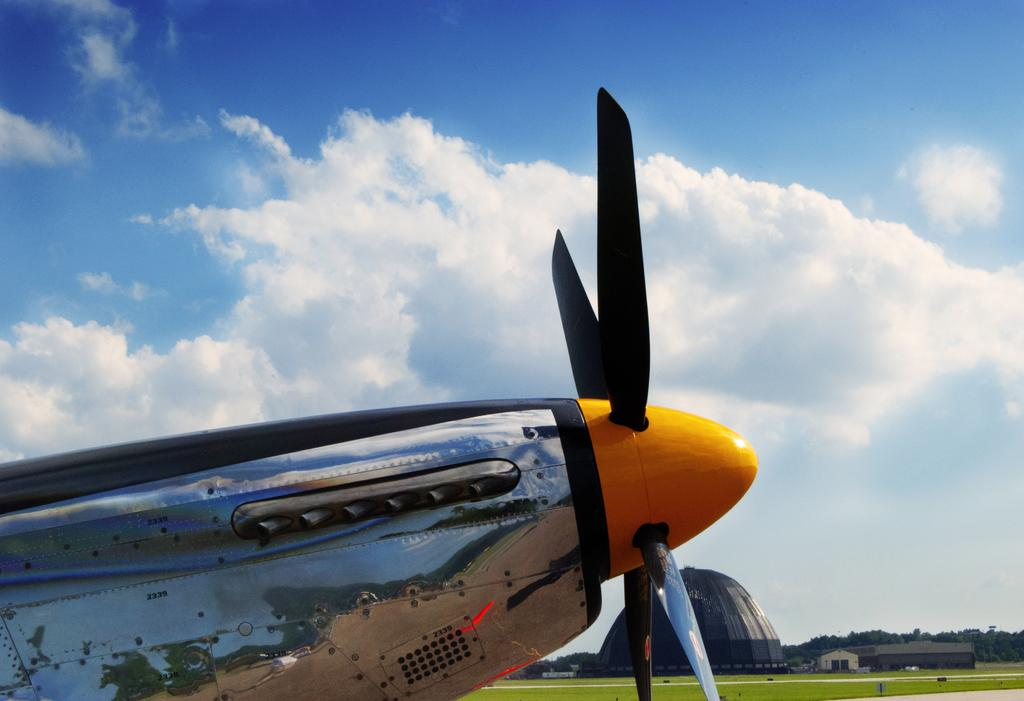What is the main subject of the image? The main subject of the image is an aircraft. What can be seen in the background of the image? The sky in the background is cloudy. What type of vegetation is on the right side of the image? There are trees and grass on the right side of the image. What type of structure is present in the image? There is a shed in the image. What is the shape of the object on the left side of the image? There is a dome-shaped object in the image. How many icicles are hanging from the aircraft in the image? There are no icicles present in the image. Can you compare the size of the aircraft to the size of the shed in the image? The size comparison between the aircraft and the shed cannot be determined from the image alone, as there is no reference for scale. 